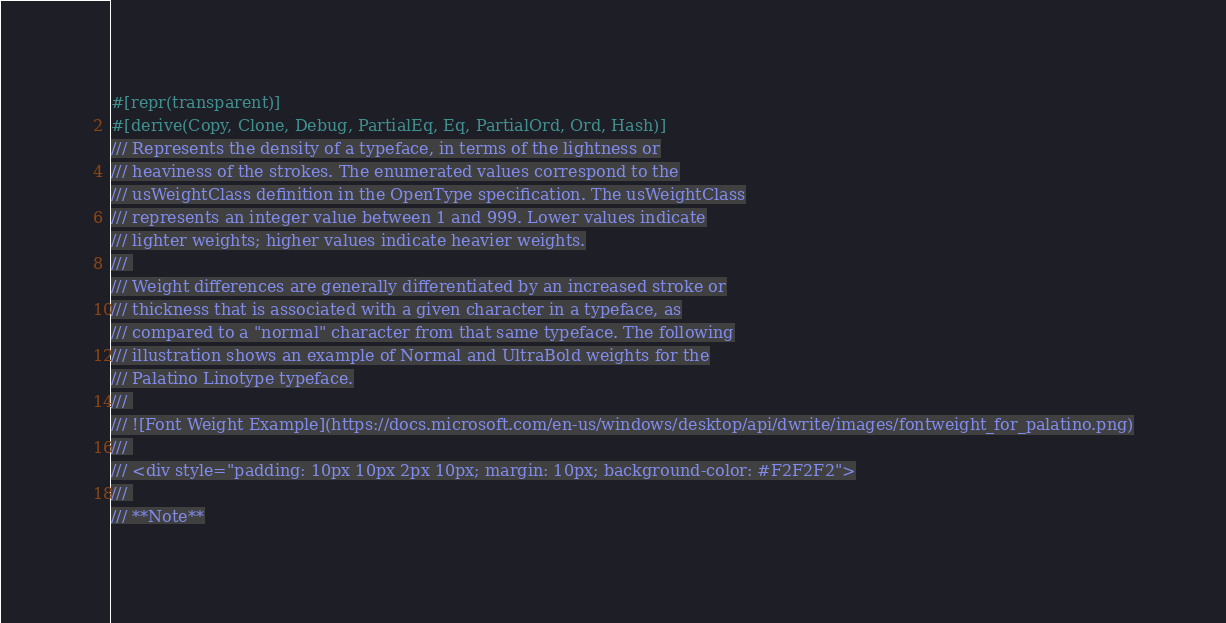Convert code to text. <code><loc_0><loc_0><loc_500><loc_500><_Rust_>#[repr(transparent)]
#[derive(Copy, Clone, Debug, PartialEq, Eq, PartialOrd, Ord, Hash)]
/// Represents the density of a typeface, in terms of the lightness or
/// heaviness of the strokes. The enumerated values correspond to the
/// usWeightClass definition in the OpenType specification. The usWeightClass
/// represents an integer value between 1 and 999. Lower values indicate
/// lighter weights; higher values indicate heavier weights.
/// 
/// Weight differences are generally differentiated by an increased stroke or
/// thickness that is associated with a given character in a typeface, as
/// compared to a "normal" character from that same typeface. The following
/// illustration shows an example of Normal and UltraBold weights for the
/// Palatino Linotype typeface.
/// 
/// ![Font Weight Example](https://docs.microsoft.com/en-us/windows/desktop/api/dwrite/images/fontweight_for_palatino.png)
/// 
/// <div style="padding: 10px 10px 2px 10px; margin: 10px; background-color: #F2F2F2">
/// 
/// **Note**</code> 